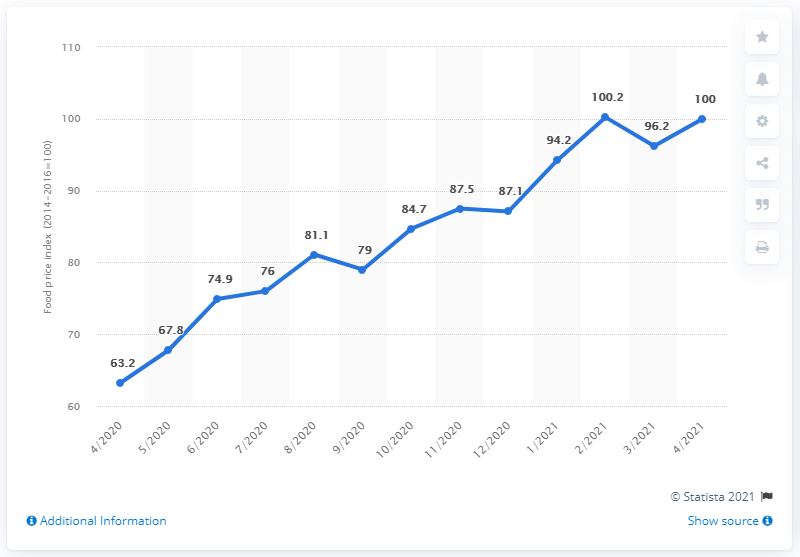List a handful of essential elements in this visual. In 2020, the difference in food prices between the 4th and 12th months was 23.9%. In February 2021, the highest price of sugar was recorded. 